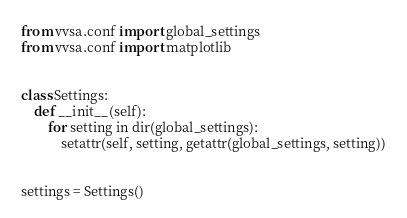<code> <loc_0><loc_0><loc_500><loc_500><_Python_>from vvsa.conf import global_settings
from vvsa.conf import matplotlib


class Settings:
    def __init__(self):
        for setting in dir(global_settings):
            setattr(self, setting, getattr(global_settings, setting))


settings = Settings()
</code> 